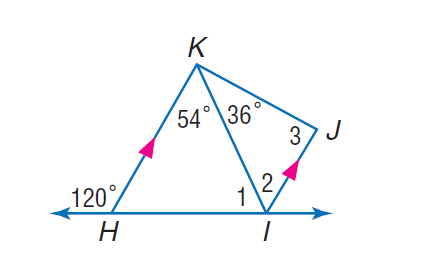Answer the mathemtical geometry problem and directly provide the correct option letter.
Question: If K H is parallel to J I, find the measure of \angle 2.
Choices: A: 36 B: 54 C: 56 D: 67 B 